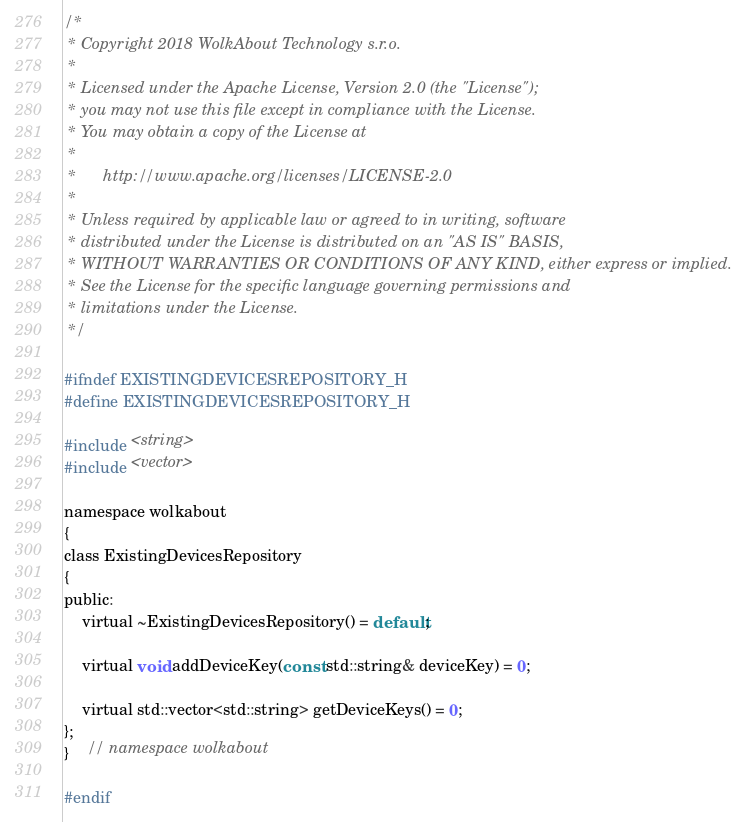Convert code to text. <code><loc_0><loc_0><loc_500><loc_500><_C_>/*
 * Copyright 2018 WolkAbout Technology s.r.o.
 *
 * Licensed under the Apache License, Version 2.0 (the "License");
 * you may not use this file except in compliance with the License.
 * You may obtain a copy of the License at
 *
 *      http://www.apache.org/licenses/LICENSE-2.0
 *
 * Unless required by applicable law or agreed to in writing, software
 * distributed under the License is distributed on an "AS IS" BASIS,
 * WITHOUT WARRANTIES OR CONDITIONS OF ANY KIND, either express or implied.
 * See the License for the specific language governing permissions and
 * limitations under the License.
 */

#ifndef EXISTINGDEVICESREPOSITORY_H
#define EXISTINGDEVICESREPOSITORY_H

#include <string>
#include <vector>

namespace wolkabout
{
class ExistingDevicesRepository
{
public:
    virtual ~ExistingDevicesRepository() = default;

    virtual void addDeviceKey(const std::string& deviceKey) = 0;

    virtual std::vector<std::string> getDeviceKeys() = 0;
};
}    // namespace wolkabout

#endif
</code> 